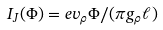Convert formula to latex. <formula><loc_0><loc_0><loc_500><loc_500>I _ { J } ( \Phi ) = e v _ { \rho } \Phi / ( \pi g _ { \rho } \ell )</formula> 